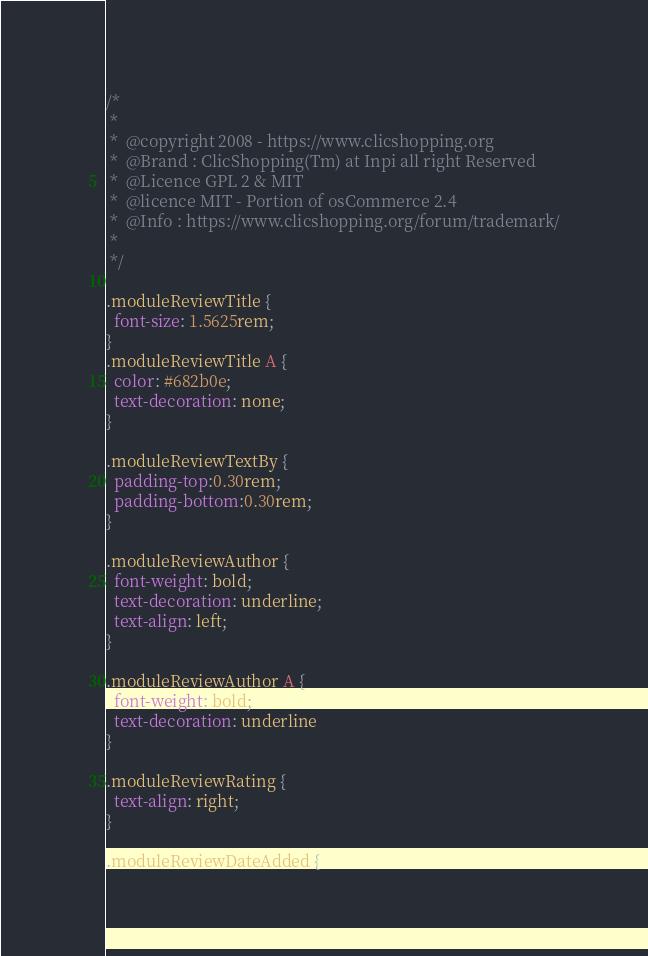Convert code to text. <code><loc_0><loc_0><loc_500><loc_500><_CSS_>/*
 *
 *  @copyright 2008 - https://www.clicshopping.org
 *  @Brand : ClicShopping(Tm) at Inpi all right Reserved
 *  @Licence GPL 2 & MIT
 *  @licence MIT - Portion of osCommerce 2.4
 *  @Info : https://www.clicshopping.org/forum/trademark/
 *
 */

.moduleReviewTitle {
  font-size: 1.5625rem;
}
.moduleReviewTitle A {
  color: #682b0e;
  text-decoration: none;
}

.moduleReviewTextBy {
  padding-top:0.30rem;
  padding-bottom:0.30rem;
}

.moduleReviewAuthor {
  font-weight: bold;
  text-decoration: underline;
  text-align: left;
}

.moduleReviewAuthor A {
  font-weight: bold;
  text-decoration: underline
}

.moduleReviewRating {
  text-align: right;
}

.moduleReviewDateAdded {</code> 